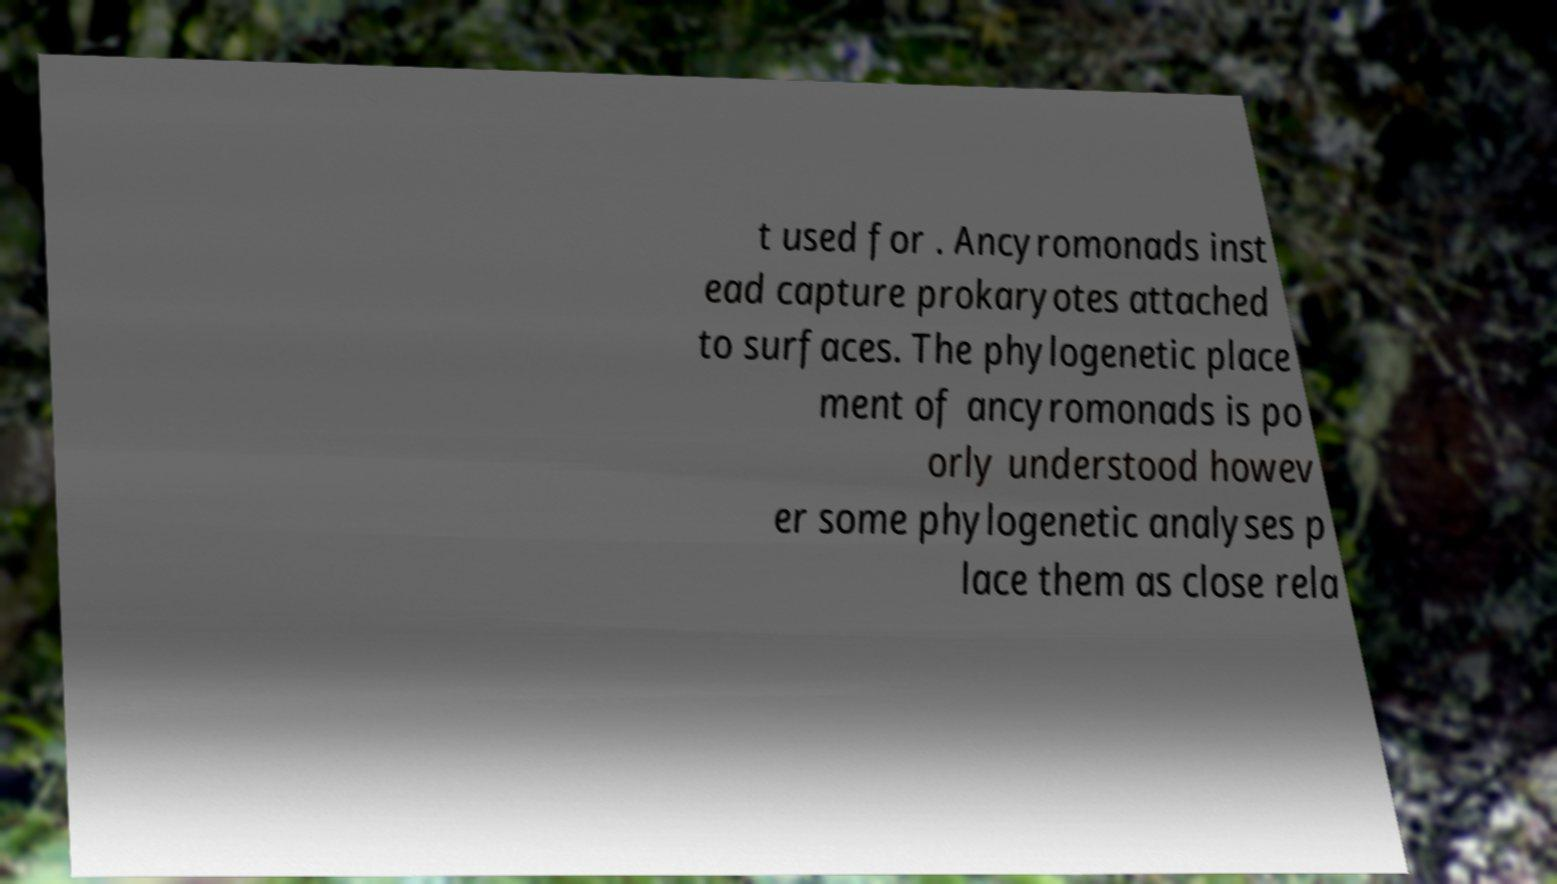Could you assist in decoding the text presented in this image and type it out clearly? t used for . Ancyromonads inst ead capture prokaryotes attached to surfaces. The phylogenetic place ment of ancyromonads is po orly understood howev er some phylogenetic analyses p lace them as close rela 